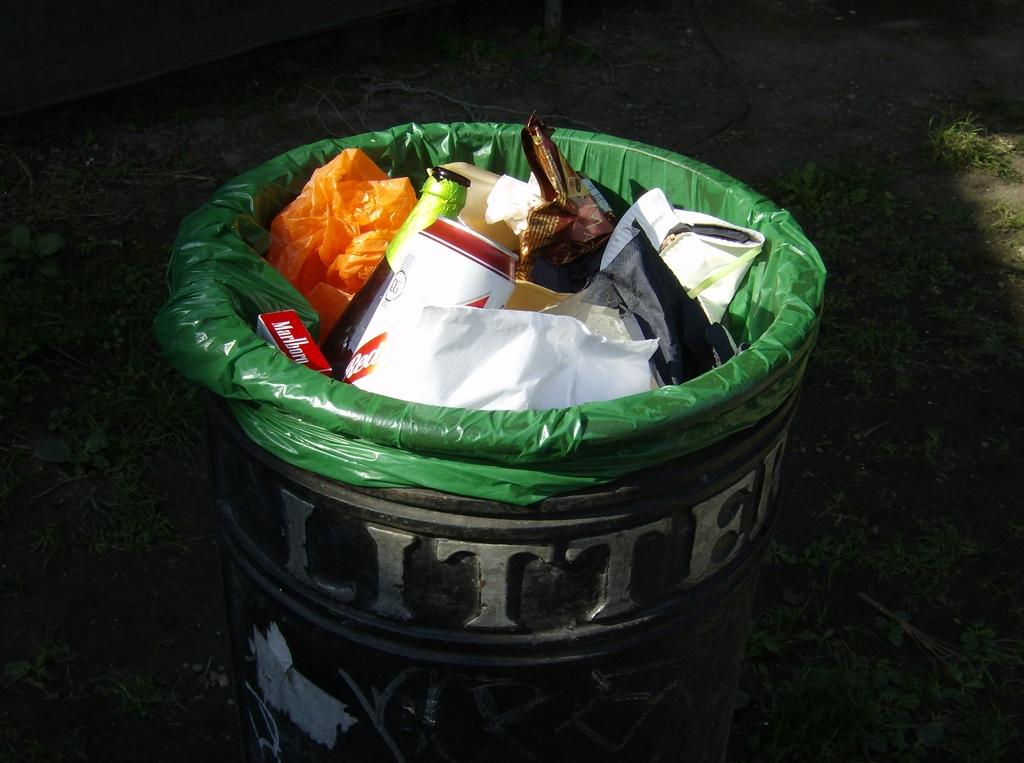What does it say on the bin?
Offer a very short reply. Litter. What is written in white on the box?
Provide a succinct answer. Litter. 